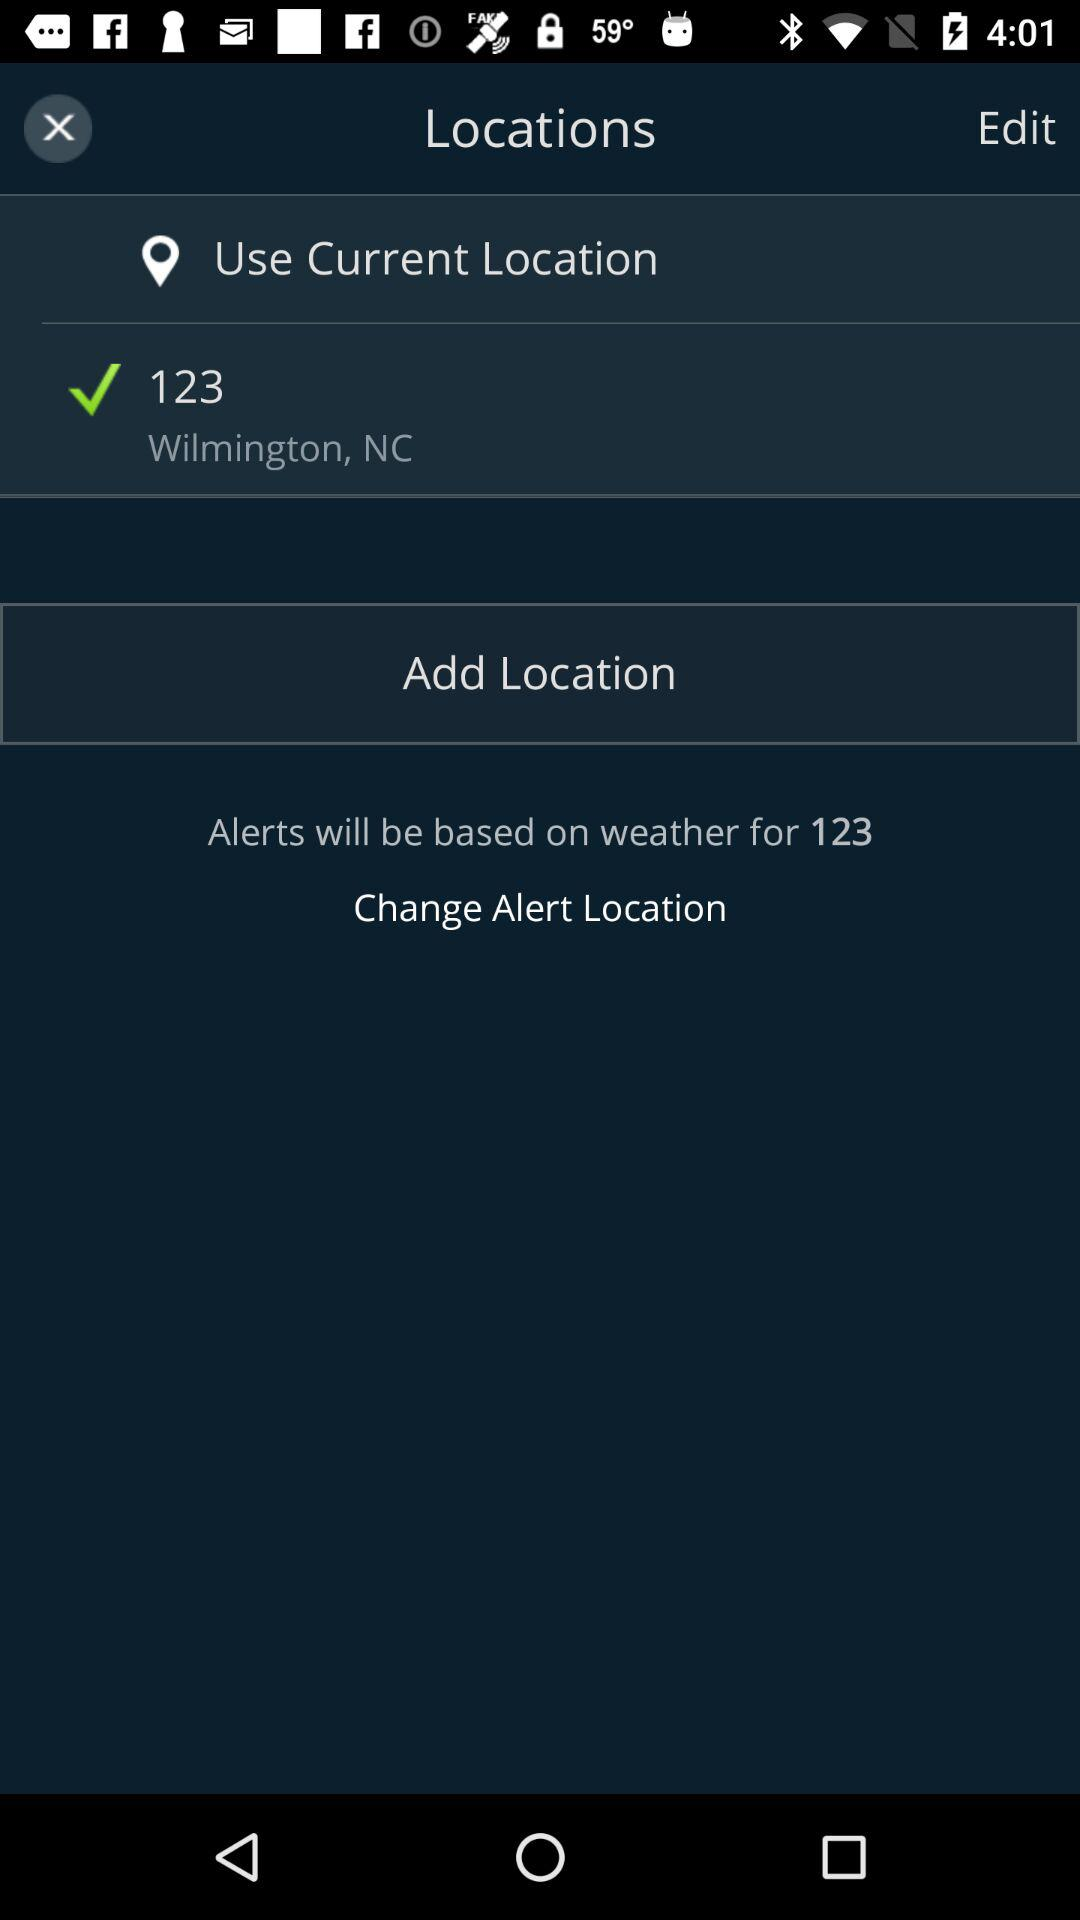How many locations are not the current location?
Answer the question using a single word or phrase. 1 